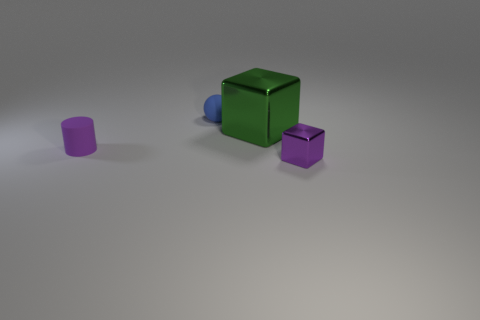Add 3 blue matte things. How many objects exist? 7 Subtract all cylinders. How many objects are left? 3 Add 1 purple things. How many purple things exist? 3 Subtract 1 purple cubes. How many objects are left? 3 Subtract all small purple metal objects. Subtract all metallic spheres. How many objects are left? 3 Add 4 blue spheres. How many blue spheres are left? 5 